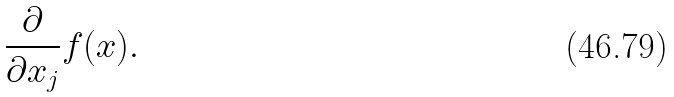Convert formula to latex. <formula><loc_0><loc_0><loc_500><loc_500>\frac { \partial } { \partial x _ { j } } f ( x ) .</formula> 